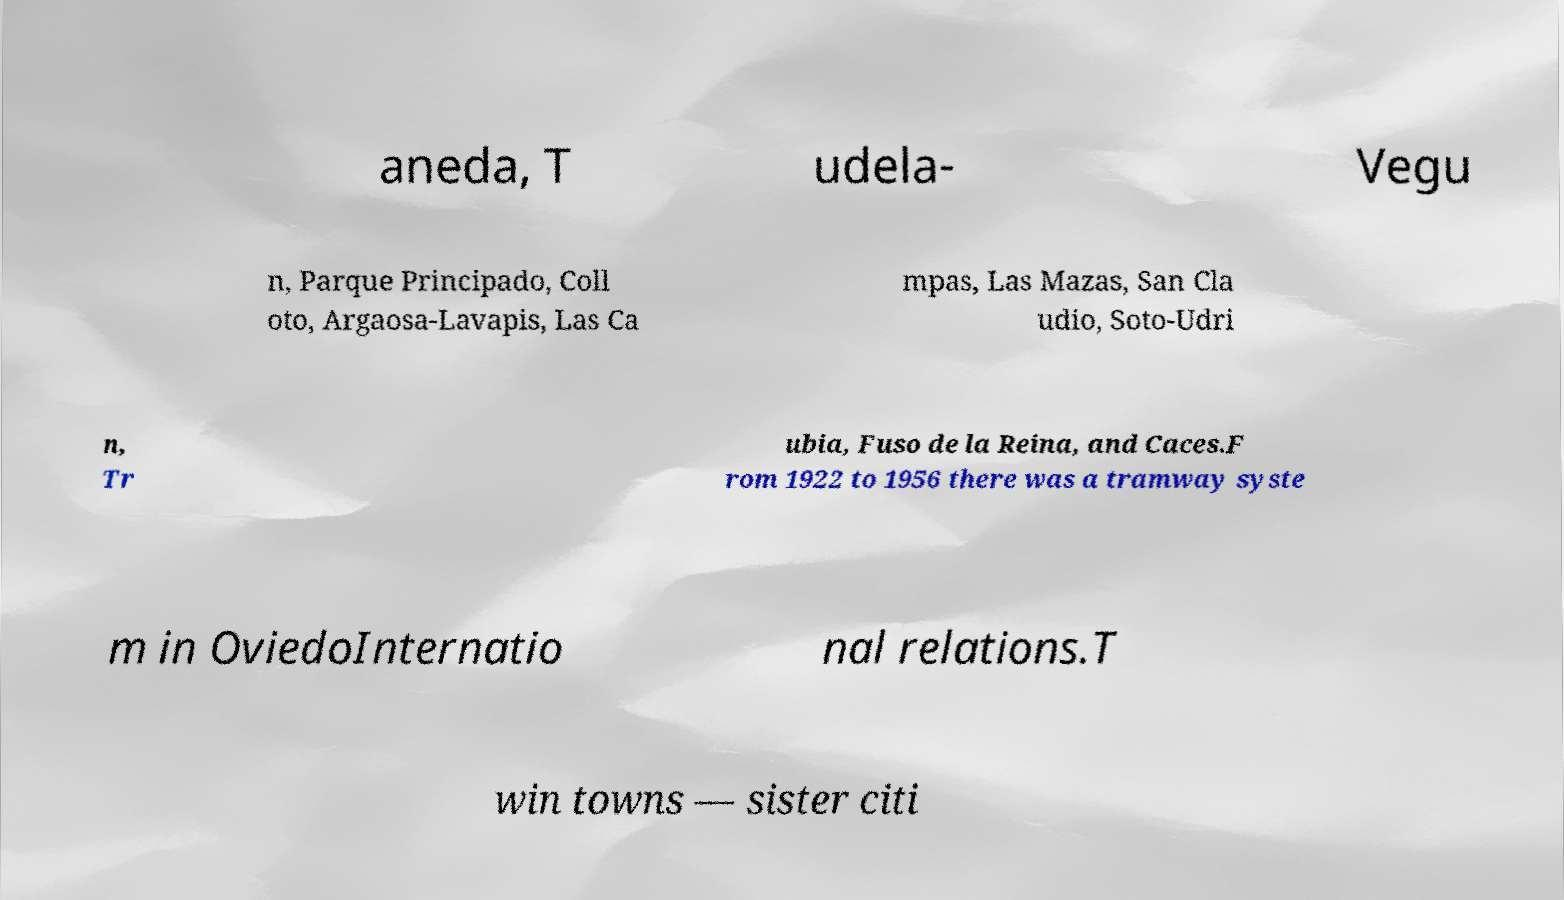Could you extract and type out the text from this image? aneda, T udela- Vegu n, Parque Principado, Coll oto, Argaosa-Lavapis, Las Ca mpas, Las Mazas, San Cla udio, Soto-Udri n, Tr ubia, Fuso de la Reina, and Caces.F rom 1922 to 1956 there was a tramway syste m in OviedoInternatio nal relations.T win towns — sister citi 